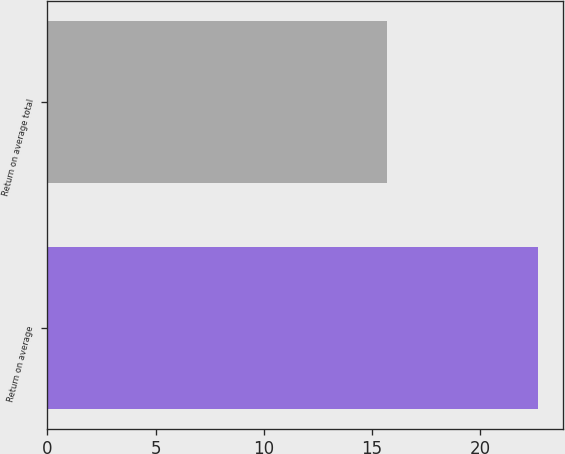Convert chart. <chart><loc_0><loc_0><loc_500><loc_500><bar_chart><fcel>Return on average<fcel>Return on average total<nl><fcel>22.7<fcel>15.7<nl></chart> 